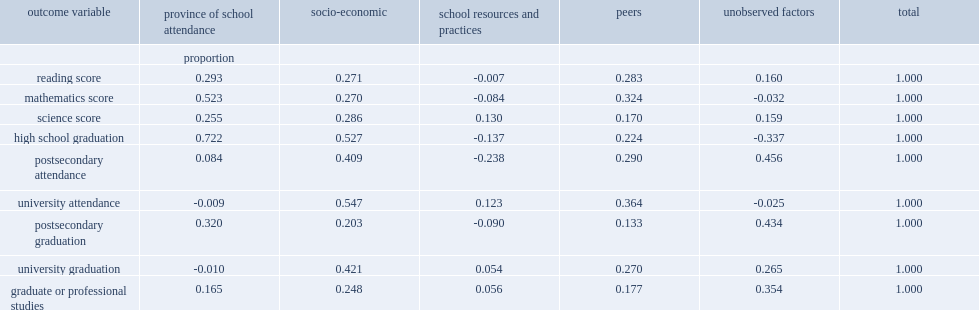Which played the least role in accounting for the differences in any of the academic outcomes? School resources and practices. How much did socio-economic characteristics ,peers and province of school attendance accounted for the difference in average reading scores respectively? 0.271 0.283 0.293. How much did socio-economic characteristics and peers accounted for the difference in university attendance respectively? 0.547 0.364. 